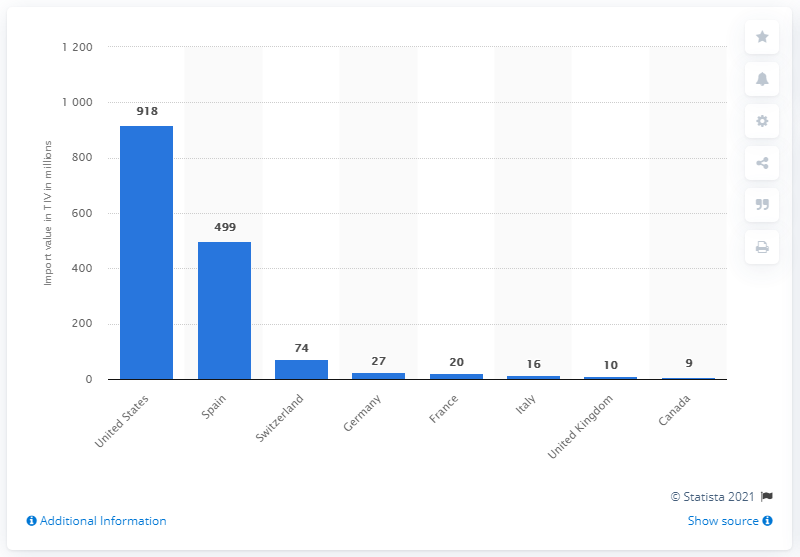List a handful of essential elements in this visual. The TIV of Australian arms imports from the United States in 2018 was 918 million US dollars. 